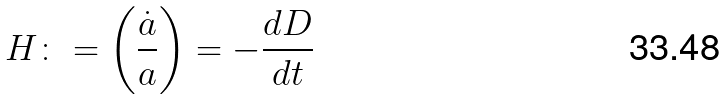<formula> <loc_0><loc_0><loc_500><loc_500>H \colon = \left ( \frac { \dot { a } } { a } \right ) = - \frac { d D } { d t }</formula> 